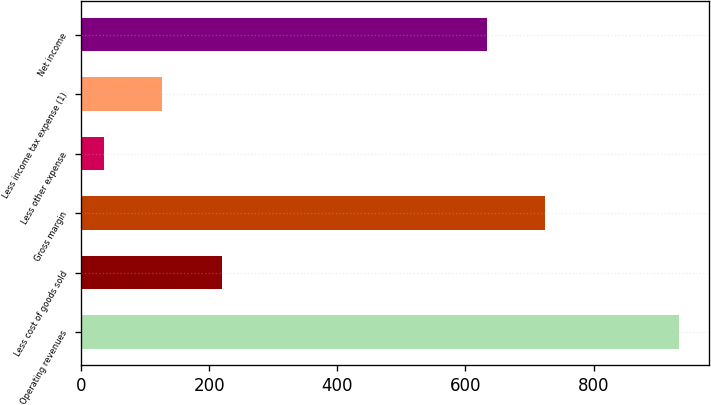Convert chart to OTSL. <chart><loc_0><loc_0><loc_500><loc_500><bar_chart><fcel>Operating revenues<fcel>Less cost of goods sold<fcel>Gross margin<fcel>Less other expense<fcel>Less income tax expense (1)<fcel>Net income<nl><fcel>934<fcel>220<fcel>723.8<fcel>36<fcel>125.8<fcel>634<nl></chart> 